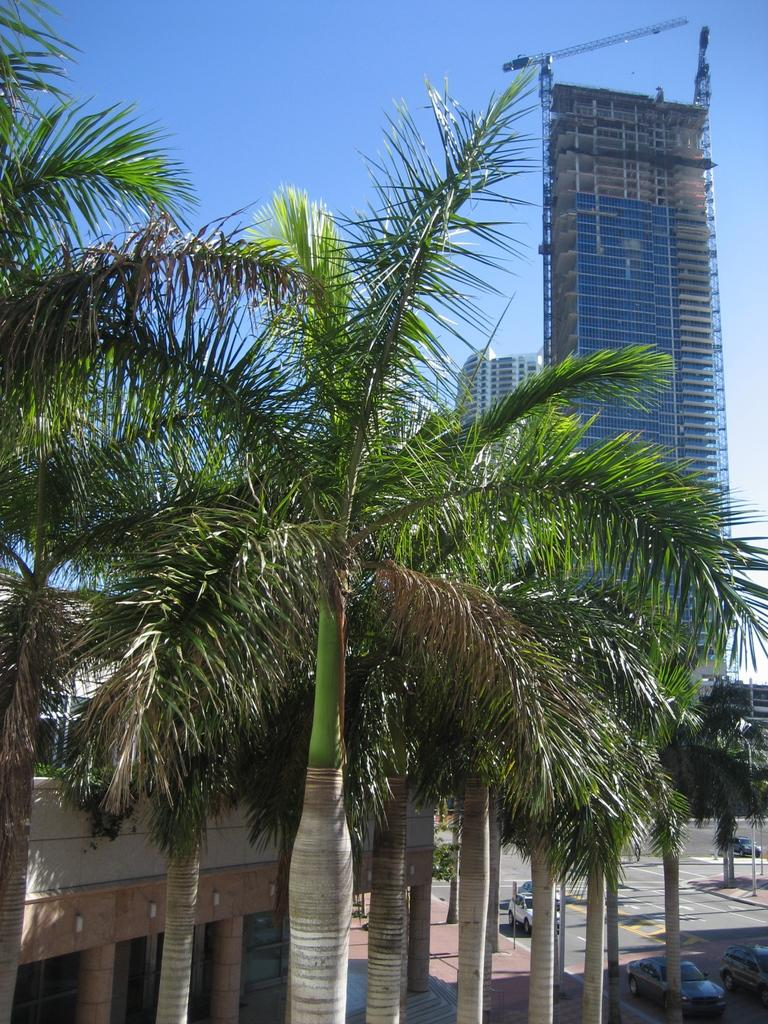What type of trees can be seen in the image? There are coconut trees in the image. What can be seen in the distance behind the trees? There are buildings in the background of the image. What mode of transportation can be seen on the road in the image? Cars are present on the road in the bottom right of the image. What is visible at the top of the image? The sky is visible at the top of the image. What type of sheet is covering the parent in the image? There is no parent or sheet present in the image. 